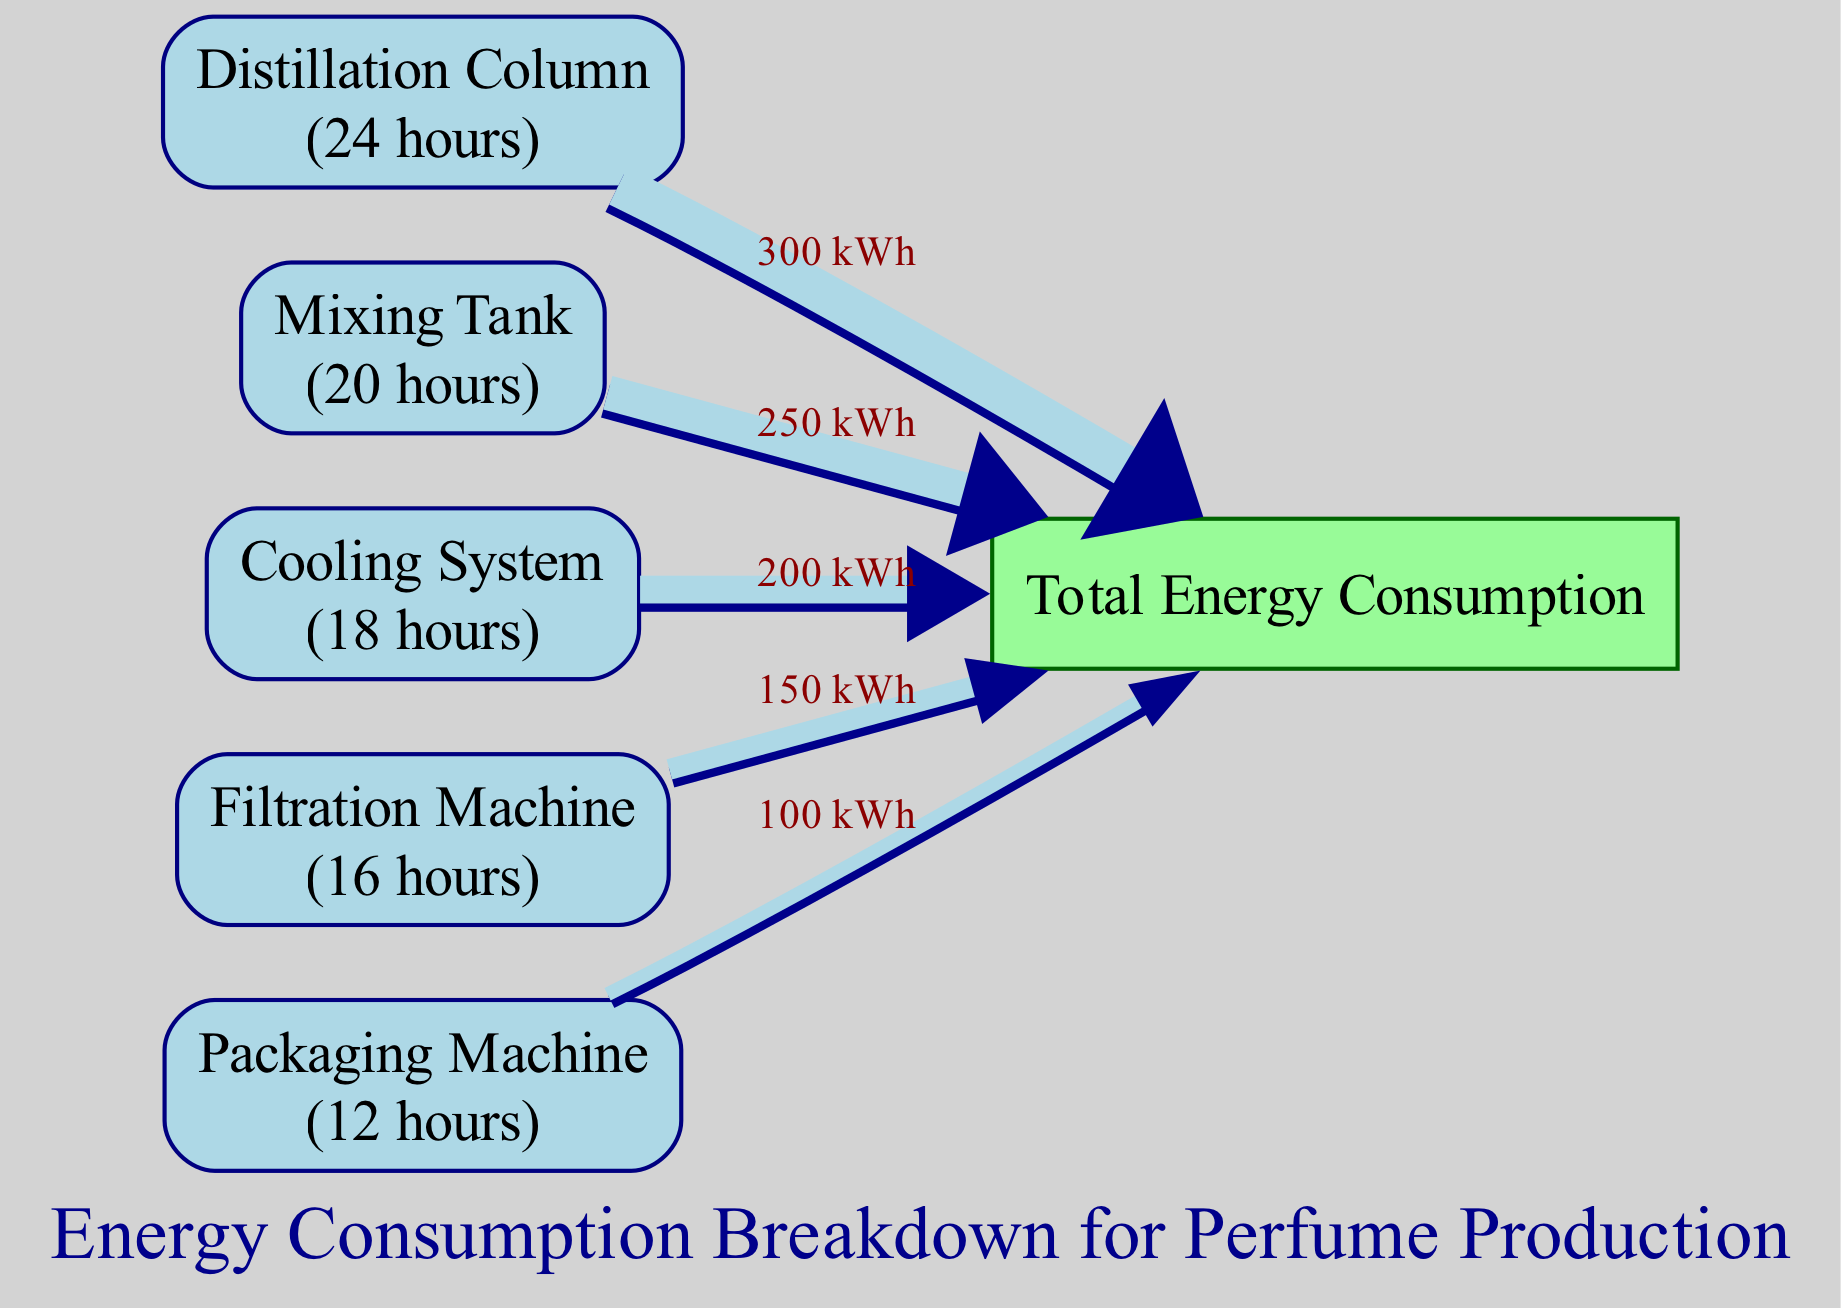What is the total energy consumption for all machinery? To find the total energy consumption, we add the energy values for all machines: 300 + 250 + 200 + 150 + 100 = 1000 kWh.
Answer: 1000 kWh Which machine consumes the most energy? By looking at the energy values, the Distillation Column has the highest consumption at 300 kWh.
Answer: Distillation Column How many machines are represented in the diagram? Count the nodes, excluding the total energy, there are five machines displayed in the diagram.
Answer: 5 What is the energy consumption of the Mixing Tank? The diagram shows the Mixing Tank consumes 250 kWh of energy.
Answer: 250 kWh Which machinery has the least operational hours? By evaluating the operational hours, the Packaging Machine operates for the least number of hours, which is 12 hours.
Answer: Packaging Machine What is the energy value for the Cooling System? The Cooling System has an energy consumption of 200 kWh, as indicated in the diagram.
Answer: 200 kWh If the total energy consumption is 1000 kWh, what percentage does the Filtration Machine contribute? The Filtration Machine consumes 150 kWh, making its contribution 15% of the total energy consumption (150/1000 * 100 = 15%).
Answer: 15% Which node has the least energy consumption? The node with the lowest energy consumption is the Packaging Machine, which consumes 100 kWh.
Answer: Packaging Machine What color represents the Total Energy Consumption node? The Total Energy Consumption node is colored dark green as shown in the diagram.
Answer: Dark Green 